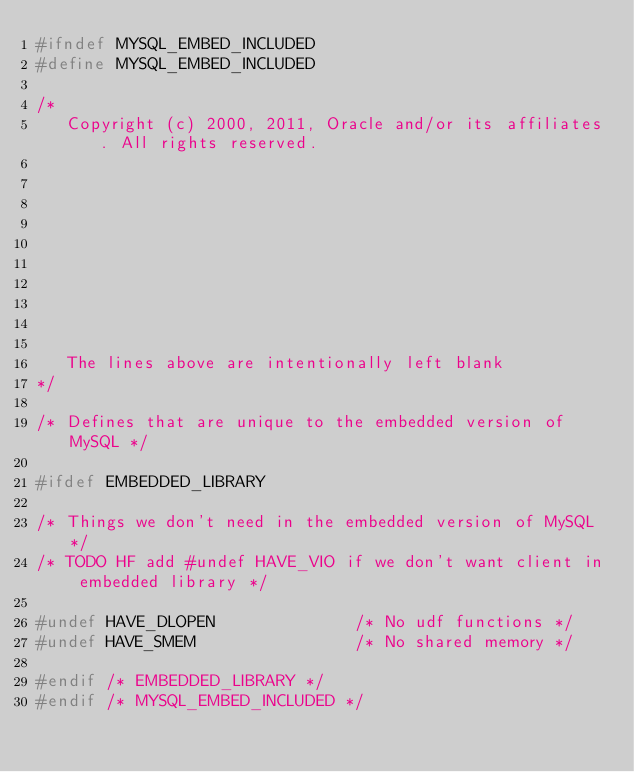Convert code to text. <code><loc_0><loc_0><loc_500><loc_500><_C_>#ifndef MYSQL_EMBED_INCLUDED
#define MYSQL_EMBED_INCLUDED

/*
   Copyright (c) 2000, 2011, Oracle and/or its affiliates. All rights reserved.










   The lines above are intentionally left blank
*/

/* Defines that are unique to the embedded version of MySQL */

#ifdef EMBEDDED_LIBRARY

/* Things we don't need in the embedded version of MySQL */
/* TODO HF add #undef HAVE_VIO if we don't want client in embedded library */

#undef HAVE_DLOPEN				/* No udf functions */
#undef HAVE_SMEM				/* No shared memory */

#endif /* EMBEDDED_LIBRARY */
#endif /* MYSQL_EMBED_INCLUDED */
</code> 